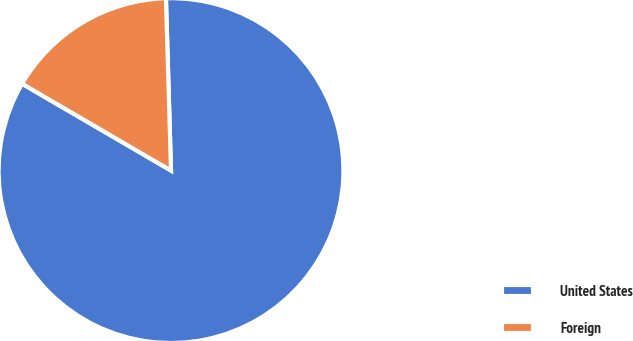Convert chart. <chart><loc_0><loc_0><loc_500><loc_500><pie_chart><fcel>United States<fcel>Foreign<nl><fcel>83.87%<fcel>16.13%<nl></chart> 